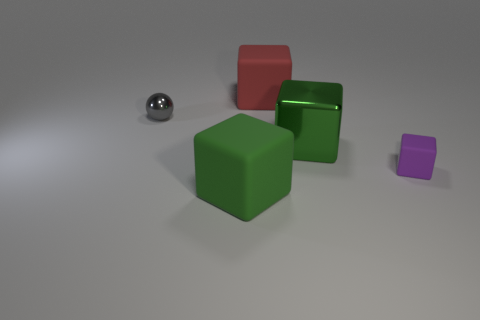How many other things are there of the same color as the large shiny cube?
Offer a terse response. 1. The block that is made of the same material as the ball is what size?
Your answer should be compact. Large. Is the number of big matte things that are on the right side of the large green metallic cube greater than the number of small purple matte cubes that are on the left side of the big red rubber object?
Ensure brevity in your answer.  No. Is there a small gray shiny object that has the same shape as the big metal thing?
Your response must be concise. No. Does the green thing that is behind the green matte object have the same size as the gray metallic sphere?
Your answer should be very brief. No. Are there any tiny gray metal things?
Provide a succinct answer. Yes. What number of objects are either large matte blocks that are right of the green rubber thing or purple rubber cubes?
Give a very brief answer. 2. Do the big metal block and the rubber object that is behind the green metal object have the same color?
Ensure brevity in your answer.  No. Are there any green cubes of the same size as the red rubber block?
Ensure brevity in your answer.  Yes. What is the object that is to the left of the large green cube in front of the green metal block made of?
Ensure brevity in your answer.  Metal. 